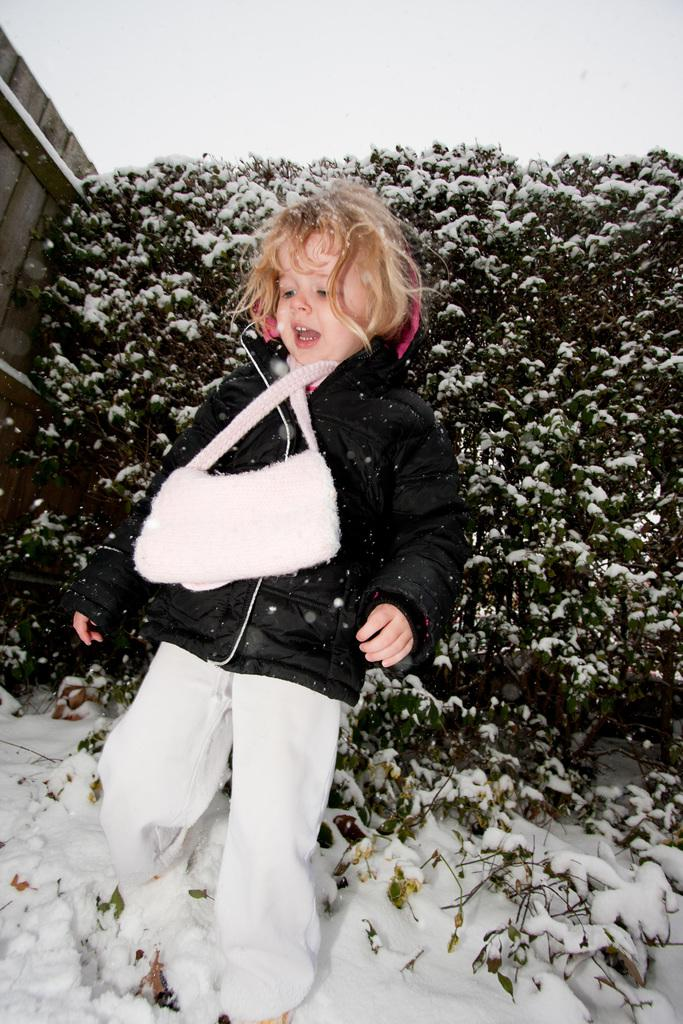What is the main subject of the image? There is a child in the image. Where is the child located in the image? The child is on the snow. What can be seen in the background of the image? There are trees and a wooden fence in the background of the image. What is visible in the sky in the image? The sky is visible in the background of the image. What type of behavior is the child exhibiting in the image? The provided facts do not mention any specific behavior of the child, so we cannot determine the child's behavior from the image. 